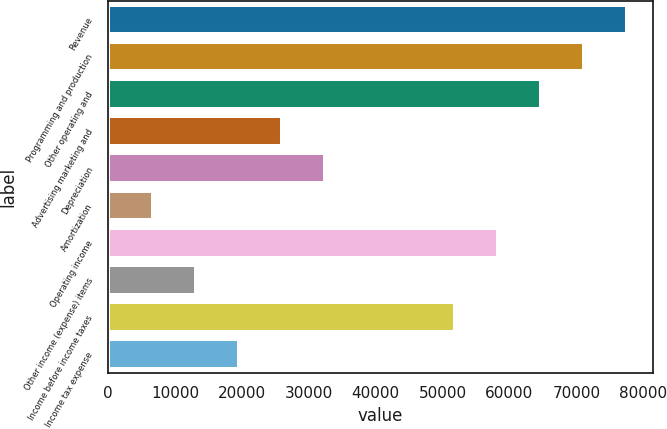Convert chart to OTSL. <chart><loc_0><loc_0><loc_500><loc_500><bar_chart><fcel>Revenue<fcel>Programming and production<fcel>Other operating and<fcel>Advertising marketing and<fcel>Depreciation<fcel>Amortization<fcel>Operating income<fcel>Other income (expense) items<fcel>Income before income taxes<fcel>Income tax expense<nl><fcel>77524.6<fcel>71090.8<fcel>64657<fcel>26054.2<fcel>32488<fcel>6752.8<fcel>58223.2<fcel>13186.6<fcel>51789.4<fcel>19620.4<nl></chart> 